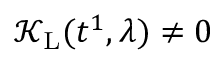<formula> <loc_0><loc_0><loc_500><loc_500>\mathcal { K } _ { L } ( t ^ { 1 } , \lambda ) \neq 0</formula> 